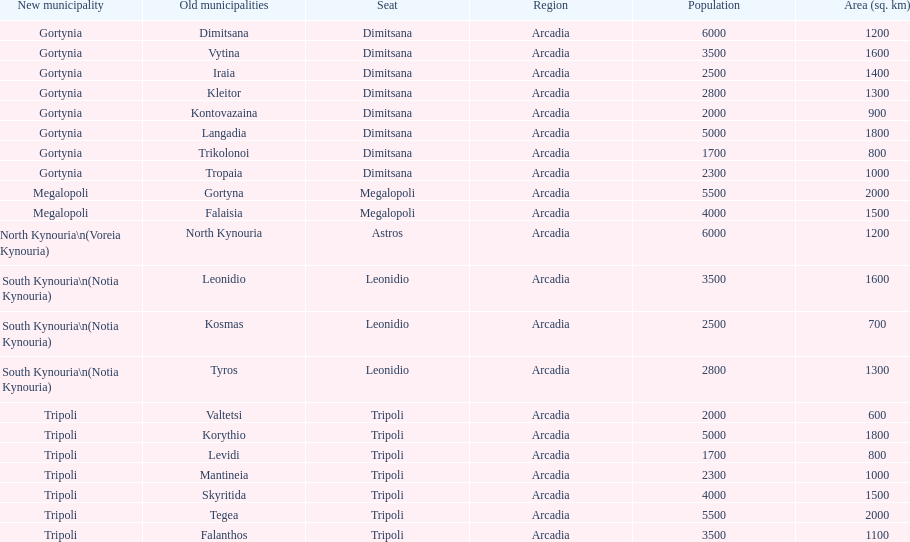When arcadia was reformed in 2011, how many municipalities were created? 5. 